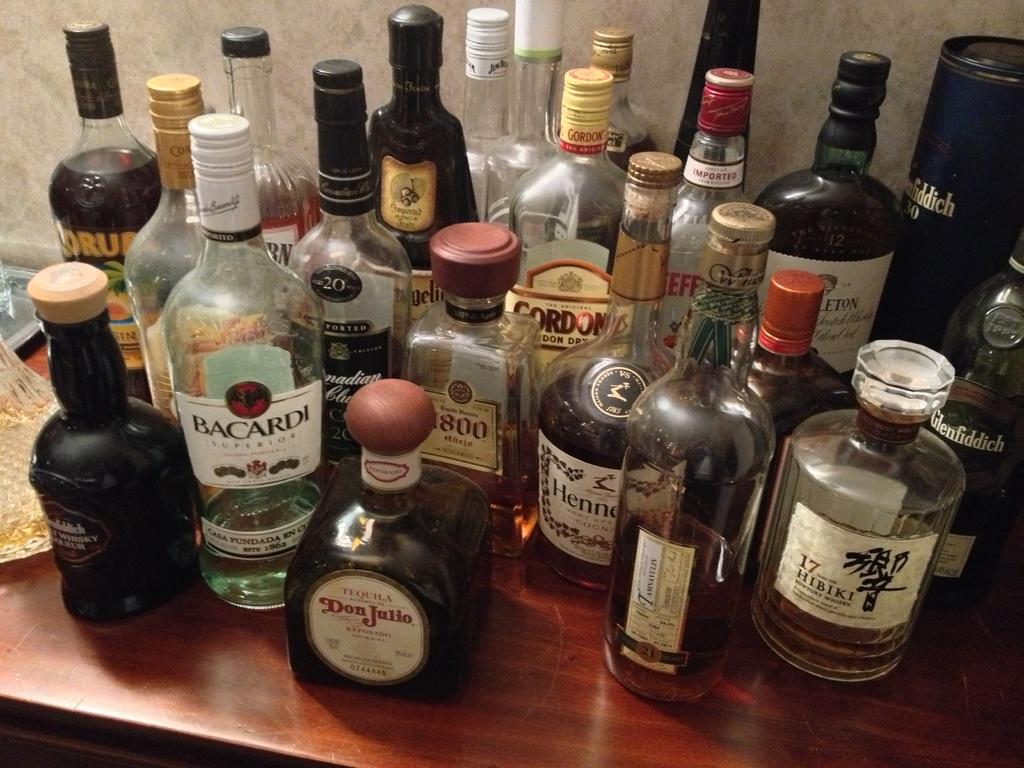What objects are on the table in the image? There are bottles on a table in the image. What can be seen in the background of the image? There is a wall visible in the background of the image. What type of peace symbol is hanging on the wall in the image? There is no peace symbol visible on the wall in the image. What flavor of jelly can be seen in the bottles on the table? There is no jelly present in the image; the bottles contain unspecified contents. 